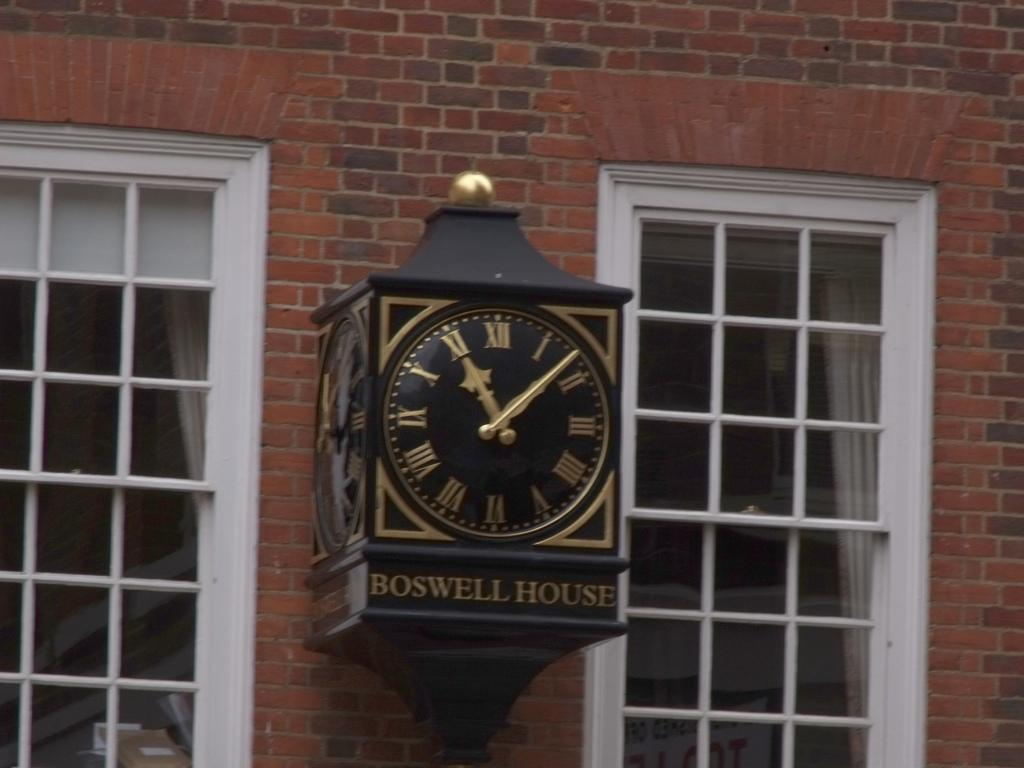<image>
Relay a brief, clear account of the picture shown. A gold and black clock and the sign Boswell House in front of a brick building. 